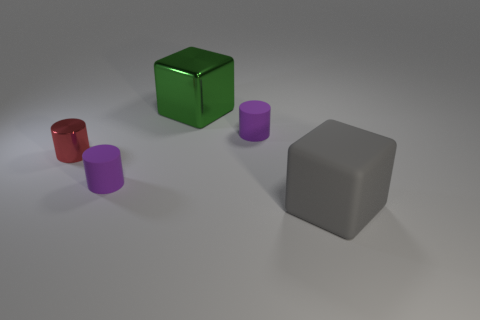Add 4 tiny red shiny cylinders. How many objects exist? 9 Subtract all cylinders. How many objects are left? 2 Subtract all big brown shiny cubes. Subtract all purple cylinders. How many objects are left? 3 Add 3 cylinders. How many cylinders are left? 6 Add 4 yellow shiny spheres. How many yellow shiny spheres exist? 4 Subtract 0 green spheres. How many objects are left? 5 